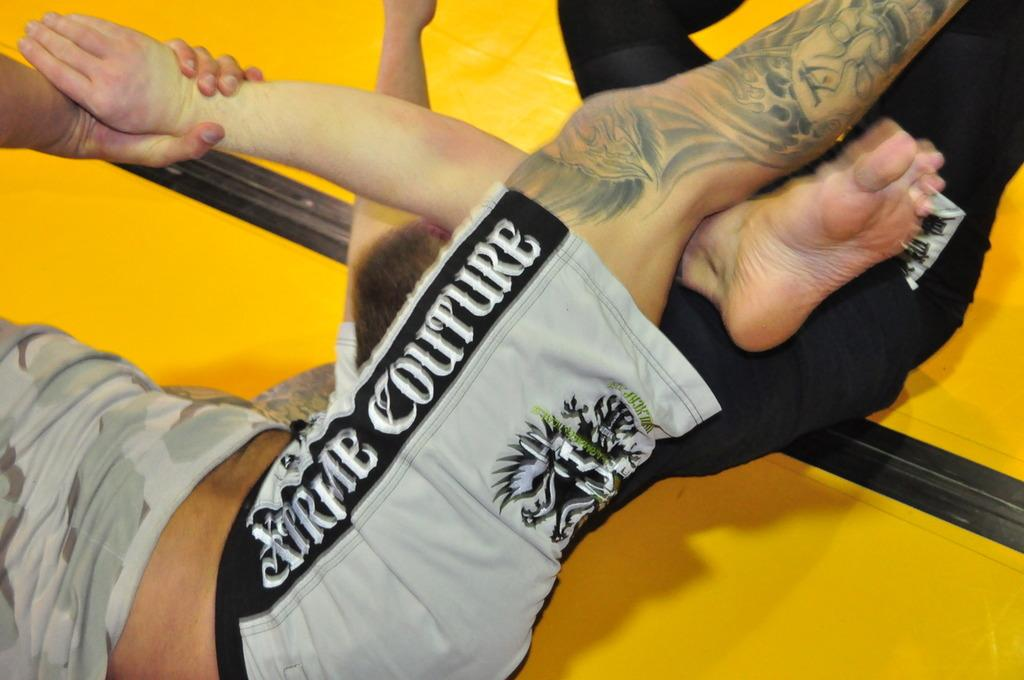<image>
Relay a brief, clear account of the picture shown. the word couture is on the shorts of a person 